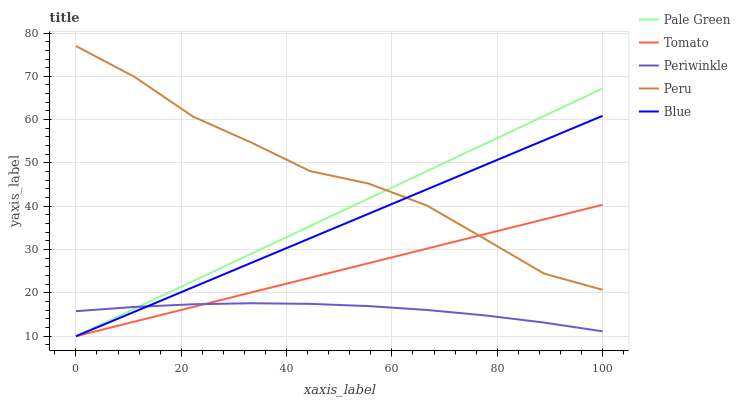Does Periwinkle have the minimum area under the curve?
Answer yes or no. Yes. Does Peru have the maximum area under the curve?
Answer yes or no. Yes. Does Blue have the minimum area under the curve?
Answer yes or no. No. Does Blue have the maximum area under the curve?
Answer yes or no. No. Is Tomato the smoothest?
Answer yes or no. Yes. Is Peru the roughest?
Answer yes or no. Yes. Is Blue the smoothest?
Answer yes or no. No. Is Blue the roughest?
Answer yes or no. No. Does Periwinkle have the lowest value?
Answer yes or no. No. Does Blue have the highest value?
Answer yes or no. No. Is Periwinkle less than Peru?
Answer yes or no. Yes. Is Peru greater than Periwinkle?
Answer yes or no. Yes. Does Periwinkle intersect Peru?
Answer yes or no. No. 